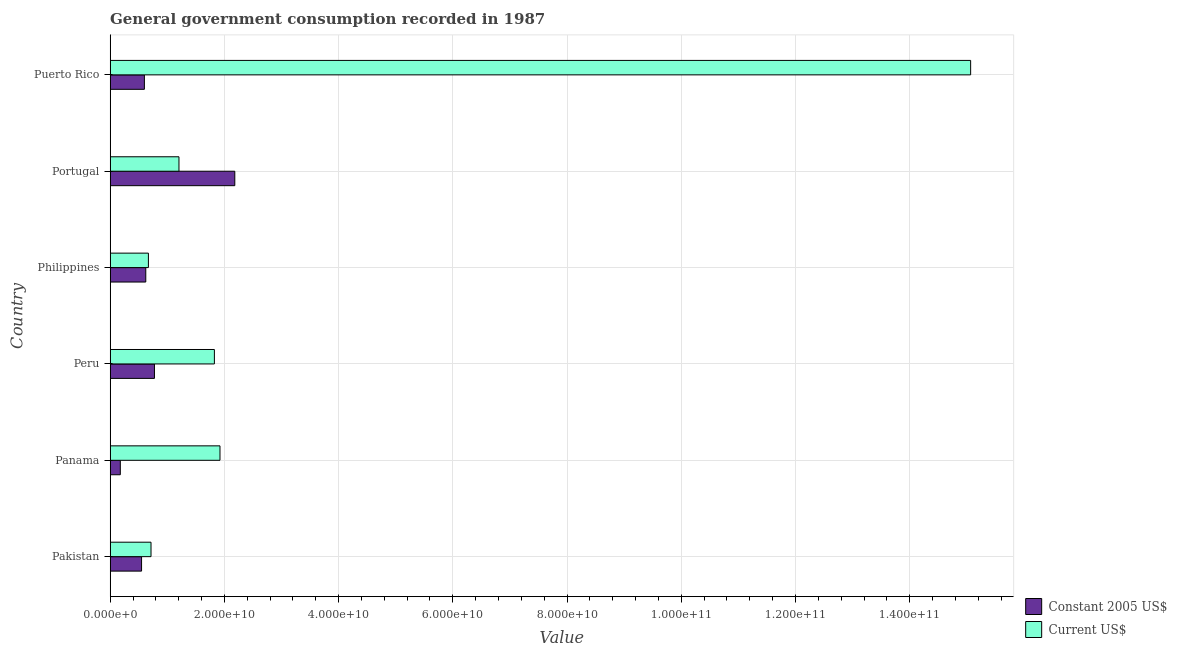How many groups of bars are there?
Offer a very short reply. 6. Are the number of bars on each tick of the Y-axis equal?
Provide a short and direct response. Yes. What is the value consumed in constant 2005 us$ in Philippines?
Give a very brief answer. 6.24e+09. Across all countries, what is the maximum value consumed in current us$?
Keep it short and to the point. 1.51e+11. Across all countries, what is the minimum value consumed in constant 2005 us$?
Give a very brief answer. 1.78e+09. In which country was the value consumed in current us$ maximum?
Offer a very short reply. Puerto Rico. What is the total value consumed in current us$ in the graph?
Give a very brief answer. 2.14e+11. What is the difference between the value consumed in constant 2005 us$ in Pakistan and that in Portugal?
Your response must be concise. -1.63e+1. What is the difference between the value consumed in constant 2005 us$ in Panama and the value consumed in current us$ in Puerto Rico?
Give a very brief answer. -1.49e+11. What is the average value consumed in constant 2005 us$ per country?
Give a very brief answer. 8.18e+09. What is the difference between the value consumed in constant 2005 us$ and value consumed in current us$ in Pakistan?
Your answer should be very brief. -1.66e+09. What is the ratio of the value consumed in current us$ in Panama to that in Portugal?
Offer a terse response. 1.6. Is the value consumed in constant 2005 us$ in Pakistan less than that in Philippines?
Offer a terse response. Yes. Is the difference between the value consumed in constant 2005 us$ in Panama and Peru greater than the difference between the value consumed in current us$ in Panama and Peru?
Give a very brief answer. No. What is the difference between the highest and the second highest value consumed in constant 2005 us$?
Offer a very short reply. 1.41e+1. What is the difference between the highest and the lowest value consumed in current us$?
Your response must be concise. 1.44e+11. In how many countries, is the value consumed in current us$ greater than the average value consumed in current us$ taken over all countries?
Ensure brevity in your answer.  1. Is the sum of the value consumed in current us$ in Pakistan and Panama greater than the maximum value consumed in constant 2005 us$ across all countries?
Offer a terse response. Yes. What does the 2nd bar from the top in Puerto Rico represents?
Your answer should be compact. Constant 2005 US$. What does the 2nd bar from the bottom in Puerto Rico represents?
Your answer should be compact. Current US$. What is the difference between two consecutive major ticks on the X-axis?
Your answer should be compact. 2.00e+1. Are the values on the major ticks of X-axis written in scientific E-notation?
Offer a very short reply. Yes. Does the graph contain any zero values?
Offer a very short reply. No. Does the graph contain grids?
Make the answer very short. Yes. Where does the legend appear in the graph?
Your response must be concise. Bottom right. How many legend labels are there?
Provide a succinct answer. 2. How are the legend labels stacked?
Offer a very short reply. Vertical. What is the title of the graph?
Give a very brief answer. General government consumption recorded in 1987. What is the label or title of the X-axis?
Your answer should be very brief. Value. What is the label or title of the Y-axis?
Provide a succinct answer. Country. What is the Value in Constant 2005 US$ in Pakistan?
Your answer should be very brief. 5.50e+09. What is the Value in Current US$ in Pakistan?
Ensure brevity in your answer.  7.16e+09. What is the Value in Constant 2005 US$ in Panama?
Ensure brevity in your answer.  1.78e+09. What is the Value in Current US$ in Panama?
Make the answer very short. 1.92e+1. What is the Value of Constant 2005 US$ in Peru?
Offer a very short reply. 7.76e+09. What is the Value of Current US$ in Peru?
Your response must be concise. 1.83e+1. What is the Value of Constant 2005 US$ in Philippines?
Your answer should be very brief. 6.24e+09. What is the Value of Current US$ in Philippines?
Provide a succinct answer. 6.70e+09. What is the Value of Constant 2005 US$ in Portugal?
Provide a short and direct response. 2.18e+1. What is the Value of Current US$ in Portugal?
Provide a succinct answer. 1.20e+1. What is the Value in Constant 2005 US$ in Puerto Rico?
Your answer should be very brief. 6.00e+09. What is the Value of Current US$ in Puerto Rico?
Provide a short and direct response. 1.51e+11. Across all countries, what is the maximum Value in Constant 2005 US$?
Your response must be concise. 2.18e+1. Across all countries, what is the maximum Value in Current US$?
Offer a very short reply. 1.51e+11. Across all countries, what is the minimum Value of Constant 2005 US$?
Your answer should be compact. 1.78e+09. Across all countries, what is the minimum Value in Current US$?
Your answer should be very brief. 6.70e+09. What is the total Value of Constant 2005 US$ in the graph?
Provide a succinct answer. 4.91e+1. What is the total Value of Current US$ in the graph?
Your response must be concise. 2.14e+11. What is the difference between the Value of Constant 2005 US$ in Pakistan and that in Panama?
Your response must be concise. 3.72e+09. What is the difference between the Value in Current US$ in Pakistan and that in Panama?
Keep it short and to the point. -1.21e+1. What is the difference between the Value in Constant 2005 US$ in Pakistan and that in Peru?
Keep it short and to the point. -2.26e+09. What is the difference between the Value of Current US$ in Pakistan and that in Peru?
Offer a terse response. -1.11e+1. What is the difference between the Value of Constant 2005 US$ in Pakistan and that in Philippines?
Your answer should be compact. -7.39e+08. What is the difference between the Value in Current US$ in Pakistan and that in Philippines?
Your response must be concise. 4.58e+08. What is the difference between the Value in Constant 2005 US$ in Pakistan and that in Portugal?
Make the answer very short. -1.63e+1. What is the difference between the Value of Current US$ in Pakistan and that in Portugal?
Your response must be concise. -4.89e+09. What is the difference between the Value in Constant 2005 US$ in Pakistan and that in Puerto Rico?
Your response must be concise. -4.96e+08. What is the difference between the Value in Current US$ in Pakistan and that in Puerto Rico?
Keep it short and to the point. -1.44e+11. What is the difference between the Value in Constant 2005 US$ in Panama and that in Peru?
Ensure brevity in your answer.  -5.98e+09. What is the difference between the Value in Current US$ in Panama and that in Peru?
Provide a short and direct response. 9.79e+08. What is the difference between the Value of Constant 2005 US$ in Panama and that in Philippines?
Give a very brief answer. -4.46e+09. What is the difference between the Value of Current US$ in Panama and that in Philippines?
Offer a very short reply. 1.25e+1. What is the difference between the Value in Constant 2005 US$ in Panama and that in Portugal?
Offer a very short reply. -2.00e+1. What is the difference between the Value in Current US$ in Panama and that in Portugal?
Offer a very short reply. 7.18e+09. What is the difference between the Value of Constant 2005 US$ in Panama and that in Puerto Rico?
Offer a very short reply. -4.22e+09. What is the difference between the Value in Current US$ in Panama and that in Puerto Rico?
Offer a terse response. -1.31e+11. What is the difference between the Value in Constant 2005 US$ in Peru and that in Philippines?
Provide a succinct answer. 1.52e+09. What is the difference between the Value of Current US$ in Peru and that in Philippines?
Provide a short and direct response. 1.16e+1. What is the difference between the Value of Constant 2005 US$ in Peru and that in Portugal?
Ensure brevity in your answer.  -1.41e+1. What is the difference between the Value in Current US$ in Peru and that in Portugal?
Your answer should be very brief. 6.20e+09. What is the difference between the Value of Constant 2005 US$ in Peru and that in Puerto Rico?
Your answer should be compact. 1.76e+09. What is the difference between the Value in Current US$ in Peru and that in Puerto Rico?
Ensure brevity in your answer.  -1.32e+11. What is the difference between the Value of Constant 2005 US$ in Philippines and that in Portugal?
Offer a terse response. -1.56e+1. What is the difference between the Value of Current US$ in Philippines and that in Portugal?
Your answer should be compact. -5.35e+09. What is the difference between the Value in Constant 2005 US$ in Philippines and that in Puerto Rico?
Your answer should be compact. 2.43e+08. What is the difference between the Value in Current US$ in Philippines and that in Puerto Rico?
Ensure brevity in your answer.  -1.44e+11. What is the difference between the Value of Constant 2005 US$ in Portugal and that in Puerto Rico?
Keep it short and to the point. 1.58e+1. What is the difference between the Value in Current US$ in Portugal and that in Puerto Rico?
Keep it short and to the point. -1.39e+11. What is the difference between the Value in Constant 2005 US$ in Pakistan and the Value in Current US$ in Panama?
Your answer should be compact. -1.37e+1. What is the difference between the Value in Constant 2005 US$ in Pakistan and the Value in Current US$ in Peru?
Offer a terse response. -1.28e+1. What is the difference between the Value in Constant 2005 US$ in Pakistan and the Value in Current US$ in Philippines?
Your answer should be compact. -1.20e+09. What is the difference between the Value in Constant 2005 US$ in Pakistan and the Value in Current US$ in Portugal?
Make the answer very short. -6.55e+09. What is the difference between the Value of Constant 2005 US$ in Pakistan and the Value of Current US$ in Puerto Rico?
Your response must be concise. -1.45e+11. What is the difference between the Value in Constant 2005 US$ in Panama and the Value in Current US$ in Peru?
Provide a succinct answer. -1.65e+1. What is the difference between the Value of Constant 2005 US$ in Panama and the Value of Current US$ in Philippines?
Make the answer very short. -4.92e+09. What is the difference between the Value in Constant 2005 US$ in Panama and the Value in Current US$ in Portugal?
Ensure brevity in your answer.  -1.03e+1. What is the difference between the Value of Constant 2005 US$ in Panama and the Value of Current US$ in Puerto Rico?
Give a very brief answer. -1.49e+11. What is the difference between the Value of Constant 2005 US$ in Peru and the Value of Current US$ in Philippines?
Your response must be concise. 1.06e+09. What is the difference between the Value of Constant 2005 US$ in Peru and the Value of Current US$ in Portugal?
Your response must be concise. -4.29e+09. What is the difference between the Value in Constant 2005 US$ in Peru and the Value in Current US$ in Puerto Rico?
Your answer should be compact. -1.43e+11. What is the difference between the Value of Constant 2005 US$ in Philippines and the Value of Current US$ in Portugal?
Keep it short and to the point. -5.81e+09. What is the difference between the Value in Constant 2005 US$ in Philippines and the Value in Current US$ in Puerto Rico?
Your answer should be very brief. -1.44e+11. What is the difference between the Value in Constant 2005 US$ in Portugal and the Value in Current US$ in Puerto Rico?
Offer a very short reply. -1.29e+11. What is the average Value in Constant 2005 US$ per country?
Provide a short and direct response. 8.18e+09. What is the average Value of Current US$ per country?
Offer a very short reply. 3.57e+1. What is the difference between the Value in Constant 2005 US$ and Value in Current US$ in Pakistan?
Give a very brief answer. -1.66e+09. What is the difference between the Value of Constant 2005 US$ and Value of Current US$ in Panama?
Offer a very short reply. -1.75e+1. What is the difference between the Value in Constant 2005 US$ and Value in Current US$ in Peru?
Make the answer very short. -1.05e+1. What is the difference between the Value of Constant 2005 US$ and Value of Current US$ in Philippines?
Give a very brief answer. -4.59e+08. What is the difference between the Value in Constant 2005 US$ and Value in Current US$ in Portugal?
Provide a succinct answer. 9.78e+09. What is the difference between the Value in Constant 2005 US$ and Value in Current US$ in Puerto Rico?
Make the answer very short. -1.45e+11. What is the ratio of the Value in Constant 2005 US$ in Pakistan to that in Panama?
Offer a very short reply. 3.09. What is the ratio of the Value of Current US$ in Pakistan to that in Panama?
Give a very brief answer. 0.37. What is the ratio of the Value of Constant 2005 US$ in Pakistan to that in Peru?
Give a very brief answer. 0.71. What is the ratio of the Value in Current US$ in Pakistan to that in Peru?
Your response must be concise. 0.39. What is the ratio of the Value in Constant 2005 US$ in Pakistan to that in Philippines?
Your response must be concise. 0.88. What is the ratio of the Value in Current US$ in Pakistan to that in Philippines?
Give a very brief answer. 1.07. What is the ratio of the Value of Constant 2005 US$ in Pakistan to that in Portugal?
Offer a terse response. 0.25. What is the ratio of the Value of Current US$ in Pakistan to that in Portugal?
Give a very brief answer. 0.59. What is the ratio of the Value in Constant 2005 US$ in Pakistan to that in Puerto Rico?
Provide a short and direct response. 0.92. What is the ratio of the Value in Current US$ in Pakistan to that in Puerto Rico?
Your answer should be very brief. 0.05. What is the ratio of the Value of Constant 2005 US$ in Panama to that in Peru?
Give a very brief answer. 0.23. What is the ratio of the Value in Current US$ in Panama to that in Peru?
Provide a short and direct response. 1.05. What is the ratio of the Value of Constant 2005 US$ in Panama to that in Philippines?
Your answer should be very brief. 0.29. What is the ratio of the Value of Current US$ in Panama to that in Philippines?
Provide a succinct answer. 2.87. What is the ratio of the Value of Constant 2005 US$ in Panama to that in Portugal?
Offer a terse response. 0.08. What is the ratio of the Value of Current US$ in Panama to that in Portugal?
Your answer should be very brief. 1.6. What is the ratio of the Value in Constant 2005 US$ in Panama to that in Puerto Rico?
Offer a terse response. 0.3. What is the ratio of the Value of Current US$ in Panama to that in Puerto Rico?
Give a very brief answer. 0.13. What is the ratio of the Value of Constant 2005 US$ in Peru to that in Philippines?
Your answer should be compact. 1.24. What is the ratio of the Value of Current US$ in Peru to that in Philippines?
Ensure brevity in your answer.  2.73. What is the ratio of the Value in Constant 2005 US$ in Peru to that in Portugal?
Provide a short and direct response. 0.36. What is the ratio of the Value in Current US$ in Peru to that in Portugal?
Ensure brevity in your answer.  1.51. What is the ratio of the Value of Constant 2005 US$ in Peru to that in Puerto Rico?
Ensure brevity in your answer.  1.29. What is the ratio of the Value in Current US$ in Peru to that in Puerto Rico?
Make the answer very short. 0.12. What is the ratio of the Value of Constant 2005 US$ in Philippines to that in Portugal?
Ensure brevity in your answer.  0.29. What is the ratio of the Value in Current US$ in Philippines to that in Portugal?
Offer a very short reply. 0.56. What is the ratio of the Value of Constant 2005 US$ in Philippines to that in Puerto Rico?
Your answer should be compact. 1.04. What is the ratio of the Value of Current US$ in Philippines to that in Puerto Rico?
Keep it short and to the point. 0.04. What is the ratio of the Value of Constant 2005 US$ in Portugal to that in Puerto Rico?
Ensure brevity in your answer.  3.64. What is the ratio of the Value of Current US$ in Portugal to that in Puerto Rico?
Your response must be concise. 0.08. What is the difference between the highest and the second highest Value of Constant 2005 US$?
Provide a short and direct response. 1.41e+1. What is the difference between the highest and the second highest Value in Current US$?
Make the answer very short. 1.31e+11. What is the difference between the highest and the lowest Value of Constant 2005 US$?
Give a very brief answer. 2.00e+1. What is the difference between the highest and the lowest Value of Current US$?
Ensure brevity in your answer.  1.44e+11. 